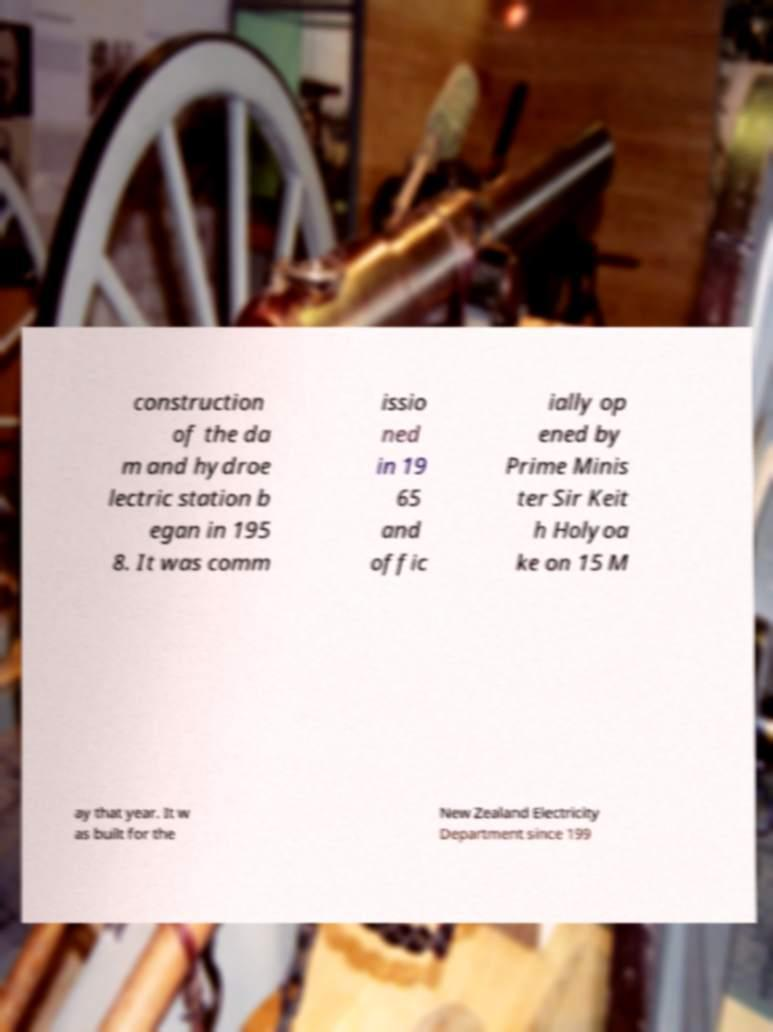Can you read and provide the text displayed in the image?This photo seems to have some interesting text. Can you extract and type it out for me? construction of the da m and hydroe lectric station b egan in 195 8. It was comm issio ned in 19 65 and offic ially op ened by Prime Minis ter Sir Keit h Holyoa ke on 15 M ay that year. It w as built for the New Zealand Electricity Department since 199 